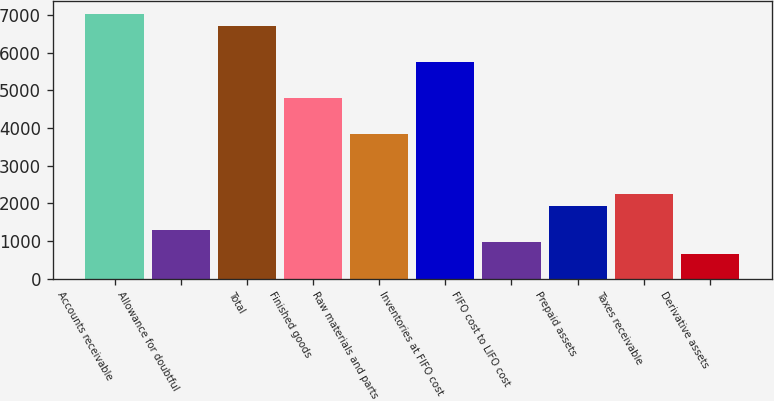Convert chart. <chart><loc_0><loc_0><loc_500><loc_500><bar_chart><fcel>Accounts receivable<fcel>Allowance for doubtful<fcel>Total<fcel>Finished goods<fcel>Raw materials and parts<fcel>Inventories at FIFO cost<fcel>FIFO cost to LIFO cost<fcel>Prepaid assets<fcel>Taxes receivable<fcel>Derivative assets<nl><fcel>7020.78<fcel>1298.76<fcel>6702.89<fcel>4795.55<fcel>3841.88<fcel>5749.22<fcel>980.87<fcel>1934.54<fcel>2252.43<fcel>662.98<nl></chart> 